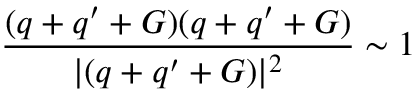<formula> <loc_0><loc_0><loc_500><loc_500>\frac { ( q + q ^ { \prime } + G ) ( q + q ^ { \prime } + G ) } { | ( q + q ^ { \prime } + G ) | ^ { 2 } } \sim 1</formula> 